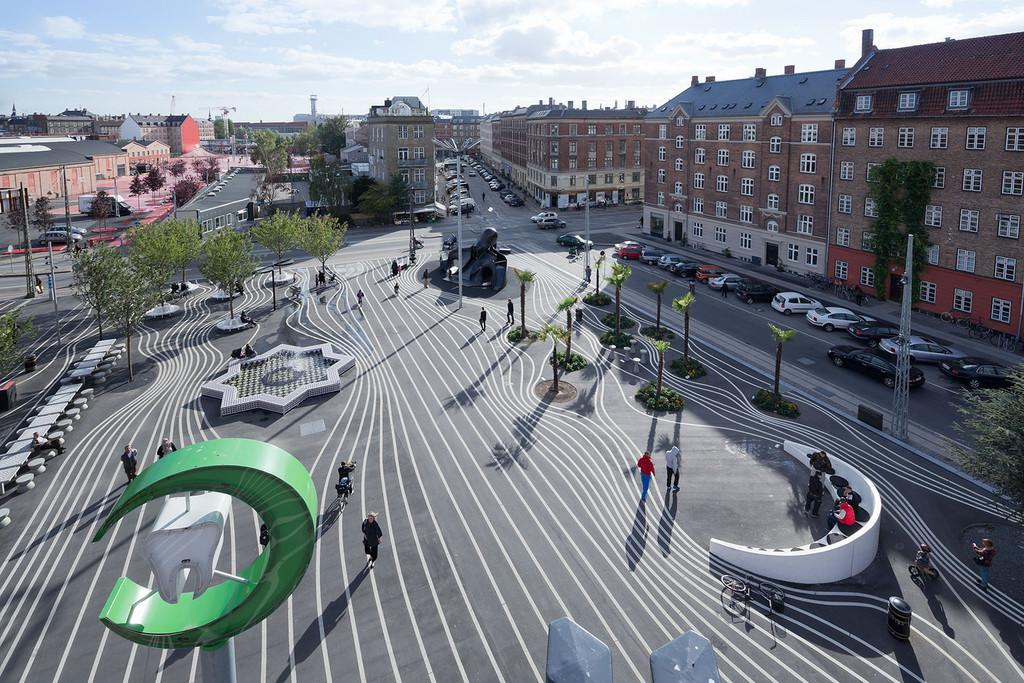Who or what can be seen in the image? There are people in the image. What else is present in the image besides people? There are vehicles, poles, trees, buildings, the ground, and the sky visible in the image. Can you describe the vehicles in the image? The provided facts do not specify the type of vehicles in the image. What is the condition of the sky in the image? The sky is visible in the image with clouds. What type of stamp is being used by the people in the image? There is no stamp present in the image. What color is the dress worn by the people in the image? The provided facts do not mention any dresses or colors worn by the people in the image. 